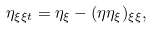<formula> <loc_0><loc_0><loc_500><loc_500>\eta _ { \xi \xi t } = \eta _ { \xi } - ( \eta \eta _ { \xi } ) _ { \xi \xi } ,</formula> 